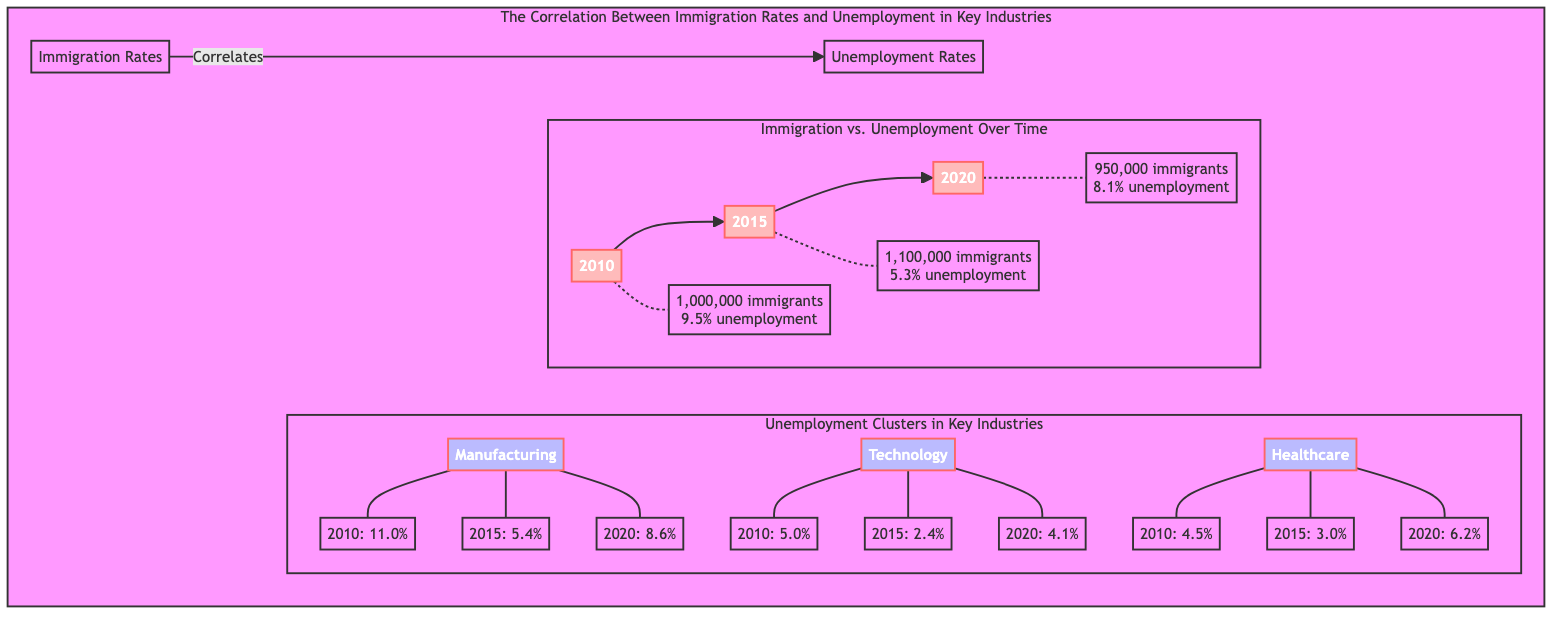What was the immigration rate in 2010? The node representing 2010 shows "1,000,000 immigrants." Therefore, the answer is directly taken from that node which denotes the value of the immigration rate in that year.
Answer: 1,000,000 immigrants What was the unemployment rate in the manufacturing sector in 2015? The 2015 unemployment rate in the manufacturing sector is indicated by the node showing "5.4%." This value is specifically stated in the diagram under the Manufacturing cluster for that year.
Answer: 5.4% How many years are depicted in the immigration versus unemployment section? The section contains three nodes representing the years 2010, 2015, and 2020. By counting these years in the flowchart, I determine that there are three distinct years presented.
Answer: 3 What is the unemployment rate in the healthcare sector in 2020? The node labeled for healthcare in 2020 states "6.2%." I reference this specific node to obtain the unemployment rate for the healthcare industry in that year.
Answer: 6.2% Which industry had the lowest unemployment rate in 2015? By examining the unemployment rates in 2015: Manufacturing at 5.4%, Technology at 2.4%, and Healthcare at 3.0%, I can compare these values. The technology sector has the lowest unemployment rate of those listed.
Answer: Technology How did the overall immigration rate change from 2010 to 2020? The immigration rate in 2010 was 1,000,000, and in 2020 it dropped to 950,000. I compare these two figures to determine the direction of the change, identifying that there was a decrease in the immigration rate over those ten years.
Answer: Decreased What was the unemployment rate in the technology sector in 2010? The technology sector's unemployment rate is explicitly identified in the diagram for the year 2010 at "5.0%." This value is taken directly from the node relevant to that industry and year.
Answer: 5.0% In which year did immigration rates peak according to the diagram? By comparing the immigration rates in the years provided, 1,000,000 in 2010 and 1,100,000 in 2015, I conclude that the peak immigration rate is represented in the year 2015 as the highest number indicated.
Answer: 2015 